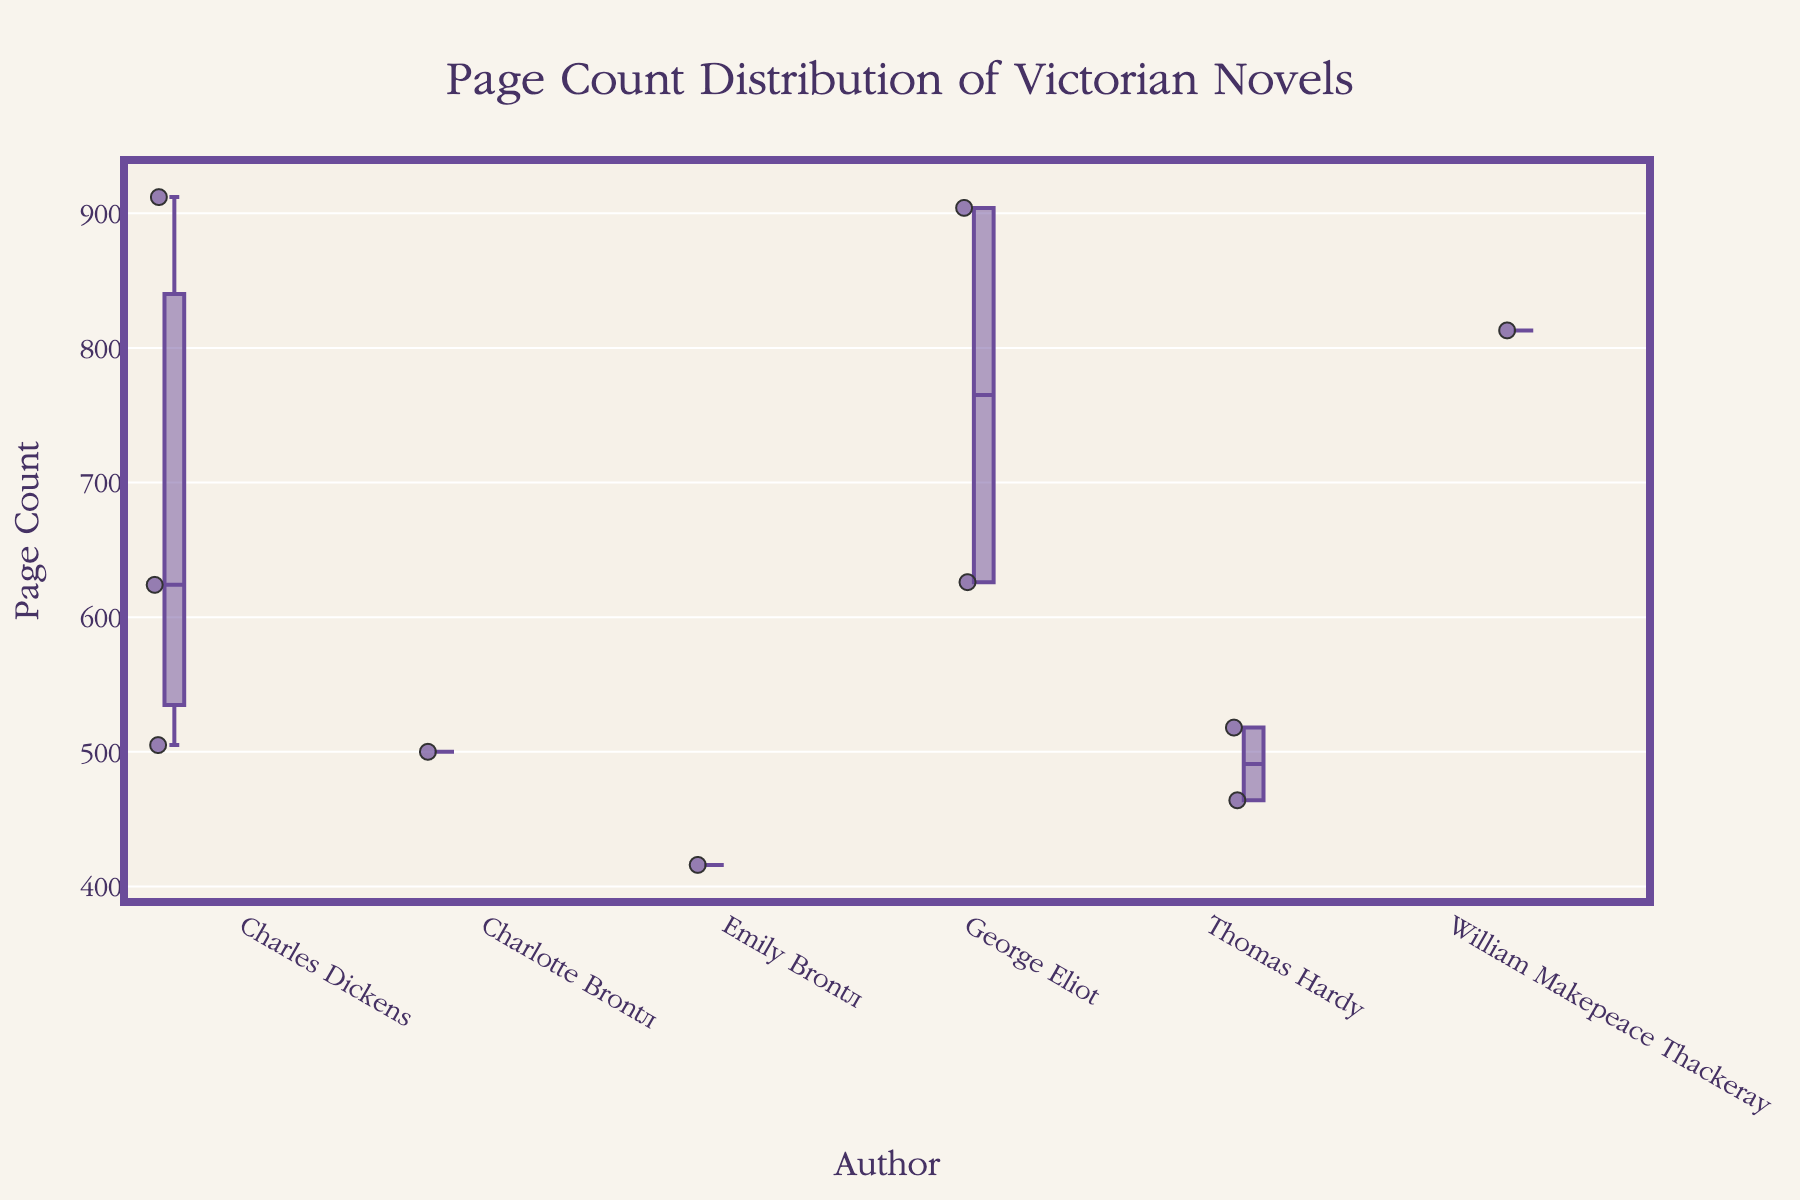what is the title of the figure The title of the figure is usually displayed at the top of the plot area. You can read it directly from there.
Answer: Page Count Distribution of Victorian Novels how many authors are included in the plot You should count the number of unique author names listed along the x-axis of the plot.
Answer: 5 which author has the novel with the highest page count Look for the data point with the highest page count on the y-axis and identify the corresponding author on the x-axis.
Answer: Charles Dickens what is the median page count for Charlotte Brontë's novels Find the boxplot for Charlotte Brontë. The median is represented by the line inside the box.
Answer: 500 how does the median page count of George Eliot's novels compare to that of Thomas Hardy Compare the lines inside the boxes of both authors' boxplots to see which one is higher.
Answer: George Eliot's median is higher which authors have novels with page counts over 800 Look for data points above 800 on the y-axis and note the authors corresponding to those points.
Answer: Charles Dickens, George Eliot, William Makepeace Thackeray what are the minimum and maximum page counts for novels by Charles Dickens The minimum is the bottom whisker, and the maximum is the top whisker of Charles Dickens' boxplot.
Answer: 505 and 912 compare the interquartile range (IQR) of Emily Brontë’s novels to that of William Makepeace Thackeray Find the length of the boxes for both authors. The IQR is the range between the bottom and top of the box.
Answer: Emily Brontë's IQR is smaller than William Makepeace Thackeray's how many novels are plotted for Thomas Hardy The boxplot will display individual points if the number of data points is small. Count these points.
Answer: 2 